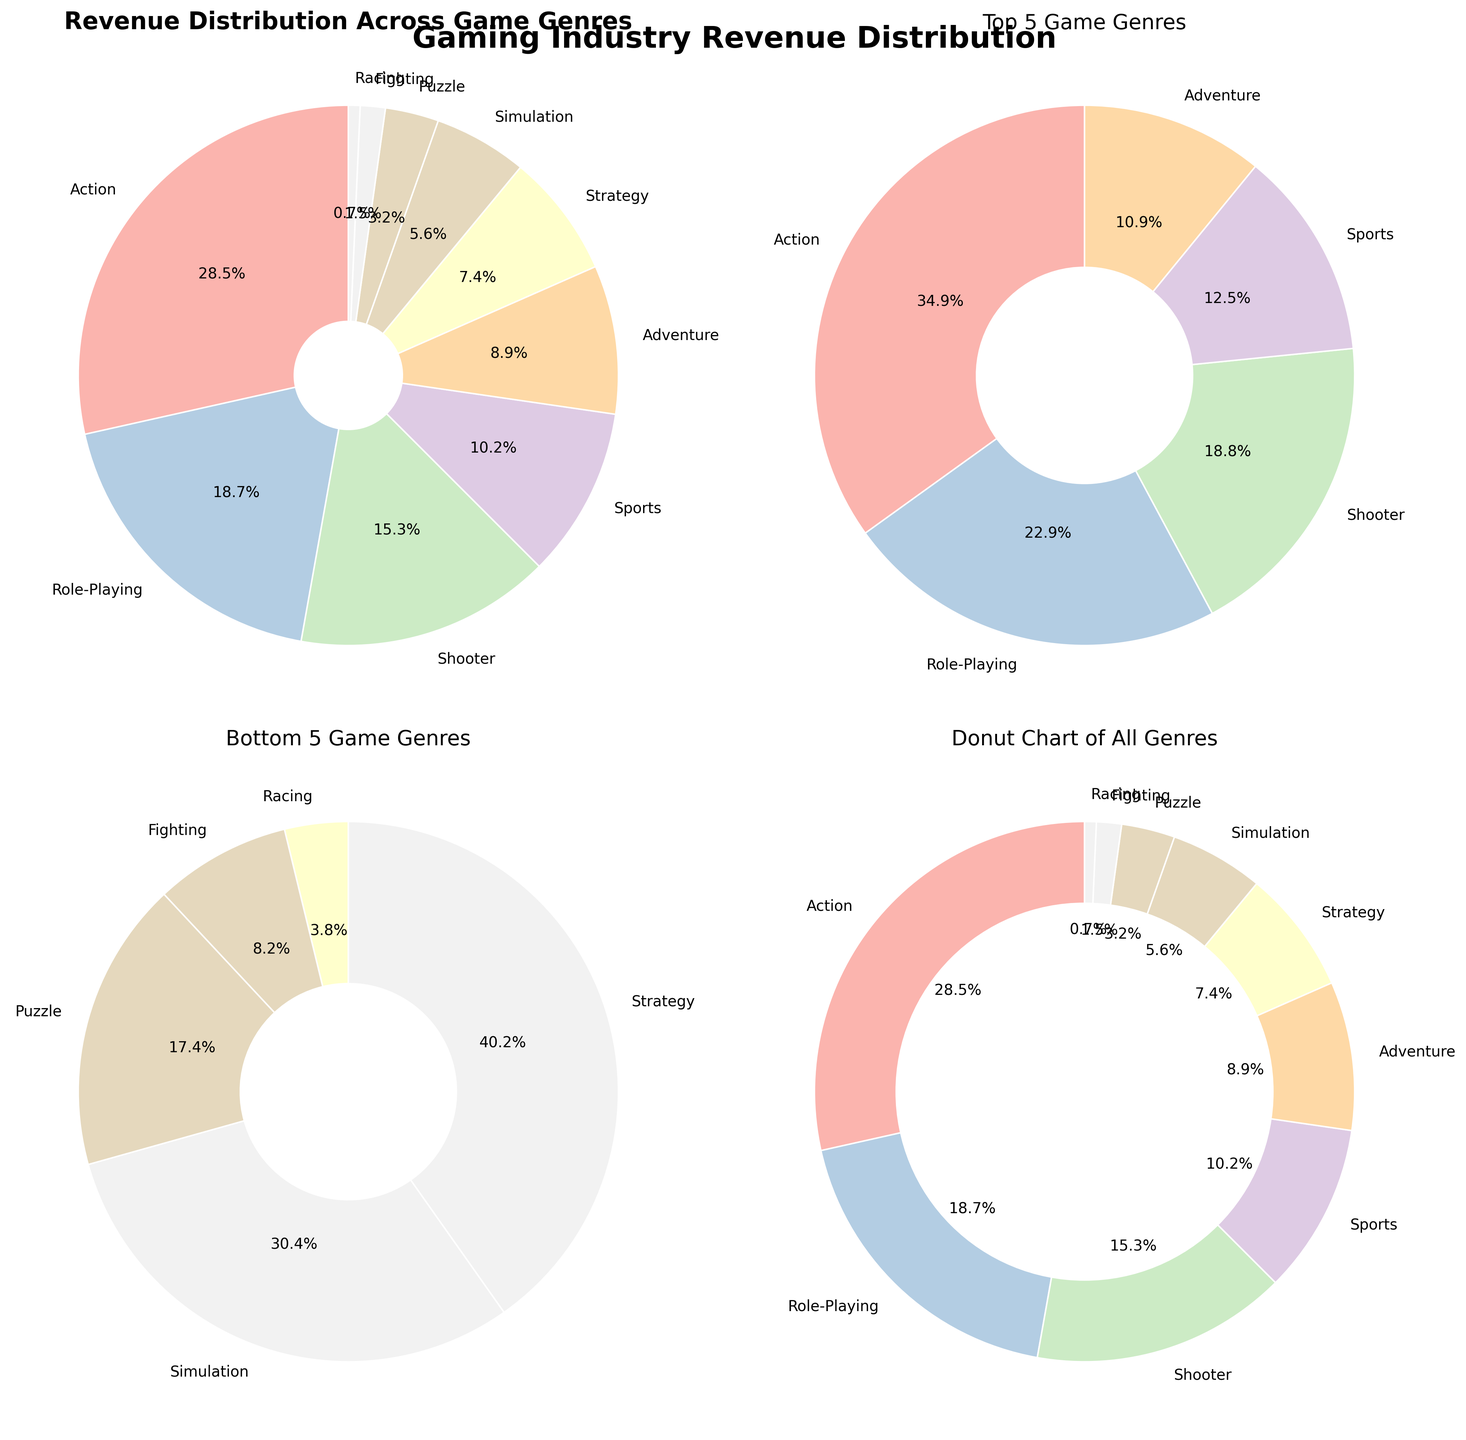Which game genre has the highest revenue percentage? Based on the pie chart titled 'Revenue Distribution Across Game Genres', the genre with the largest segment is Action, which has a revenue percentage of 28.5%.
Answer: Action How many total game genres are represented in the full pie chart? The full pie chart includes labels for each segment corresponding to a game genre. There are a total of 10 labels, indicating 10 different game genres.
Answer: 10 What is the combined revenue percentage of the top 5 game genres? Summing the revenue percentages of the top 5 genres: Action (28.5) + Role-Playing (18.7) + Shooter (15.3) + Sports (10.2) + Adventure (8.9) gives 81.6.
Answer: 81.6% Which game genre has the lowest revenue percentage among the bottom 5? The pie chart for the bottom 5 game genres shows the smallest segment corresponds to Racing with a revenue percentage of 0.7%.
Answer: Racing What is the revenue percentage difference between the Adventure and Simulation genres? From the full pie chart, Adventure has a revenue percentage of 8.9%, and Simulation has 5.6%. The difference is 8.9 - 5.6 = 3.3%.
Answer: 3.3% Which game genres are included in the donut chart? The donut chart includes all the game genres represented in the data, which are Action, Role-Playing, Shooter, Sports, Adventure, Strategy, Simulation, Puzzle, Fighting, and Racing.
Answer: All genres Which pie chart shows the genres with revenue percentages closest to the average revenue percentage? The pie chart for the bottom 5 game genres includes genres with revenue percentages (7.4, 5.6, 3.2, 1.5, 0.7) that are closer to the average revenue percentage for all genres.
Answer: Bottom 5 genres What is the central circle color in the donut chart? The central circle color in the donut chart is white, which can be identified by observing the inner circle in the donut chart.
Answer: White 